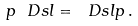<formula> <loc_0><loc_0><loc_500><loc_500>p \ D s l = \ D s l p \, .</formula> 